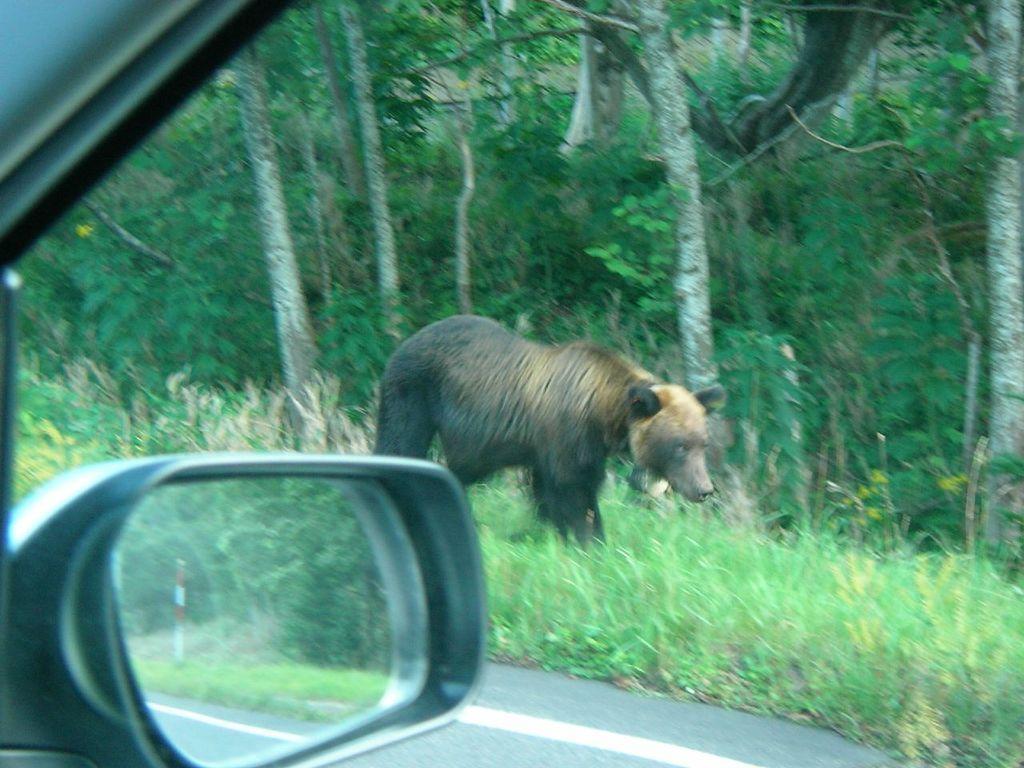Describe this image in one or two sentences. In this image I can see the vehicle on the road. To the side of the vehicle I can see an animal which is in brown and black color. It is on the grass. To the side of an animal I can see many trees. 